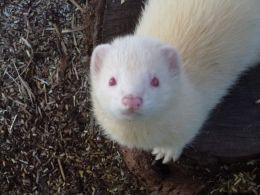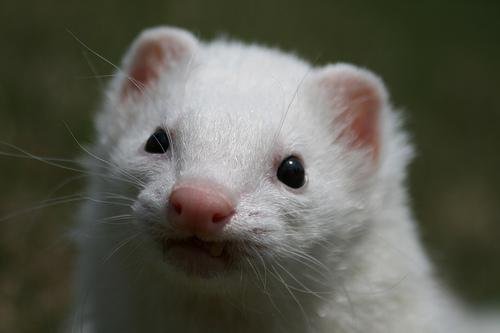The first image is the image on the left, the second image is the image on the right. Given the left and right images, does the statement "A person is holding up the animal in one of the images." hold true? Answer yes or no. No. The first image is the image on the left, the second image is the image on the right. For the images displayed, is the sentence "a white ferret is being held in a human hand" factually correct? Answer yes or no. No. 